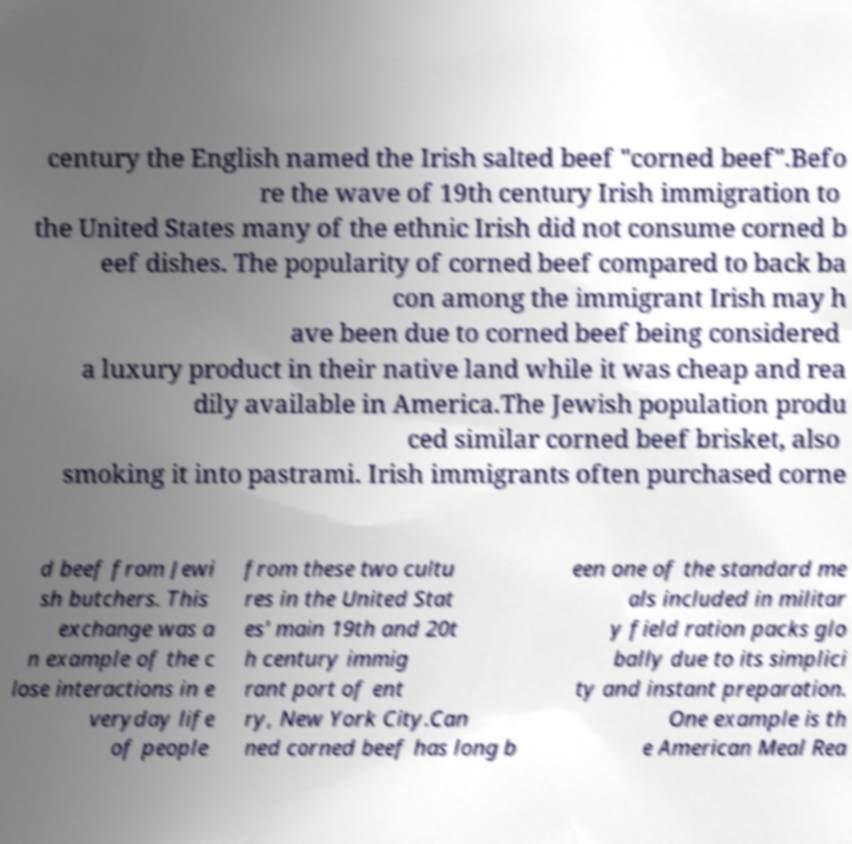Can you accurately transcribe the text from the provided image for me? century the English named the Irish salted beef "corned beef".Befo re the wave of 19th century Irish immigration to the United States many of the ethnic Irish did not consume corned b eef dishes. The popularity of corned beef compared to back ba con among the immigrant Irish may h ave been due to corned beef being considered a luxury product in their native land while it was cheap and rea dily available in America.The Jewish population produ ced similar corned beef brisket, also smoking it into pastrami. Irish immigrants often purchased corne d beef from Jewi sh butchers. This exchange was a n example of the c lose interactions in e veryday life of people from these two cultu res in the United Stat es' main 19th and 20t h century immig rant port of ent ry, New York City.Can ned corned beef has long b een one of the standard me als included in militar y field ration packs glo bally due to its simplici ty and instant preparation. One example is th e American Meal Rea 